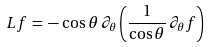Convert formula to latex. <formula><loc_0><loc_0><loc_500><loc_500>L f \, = \, - \, \cos \theta \, \partial _ { \theta } \left ( \frac { 1 } { \cos \theta } \, \partial _ { \theta } f \right )</formula> 